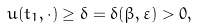Convert formula to latex. <formula><loc_0><loc_0><loc_500><loc_500>u ( t _ { 1 } , \cdot ) \geq \delta = \delta ( \beta , \varepsilon ) > 0 ,</formula> 